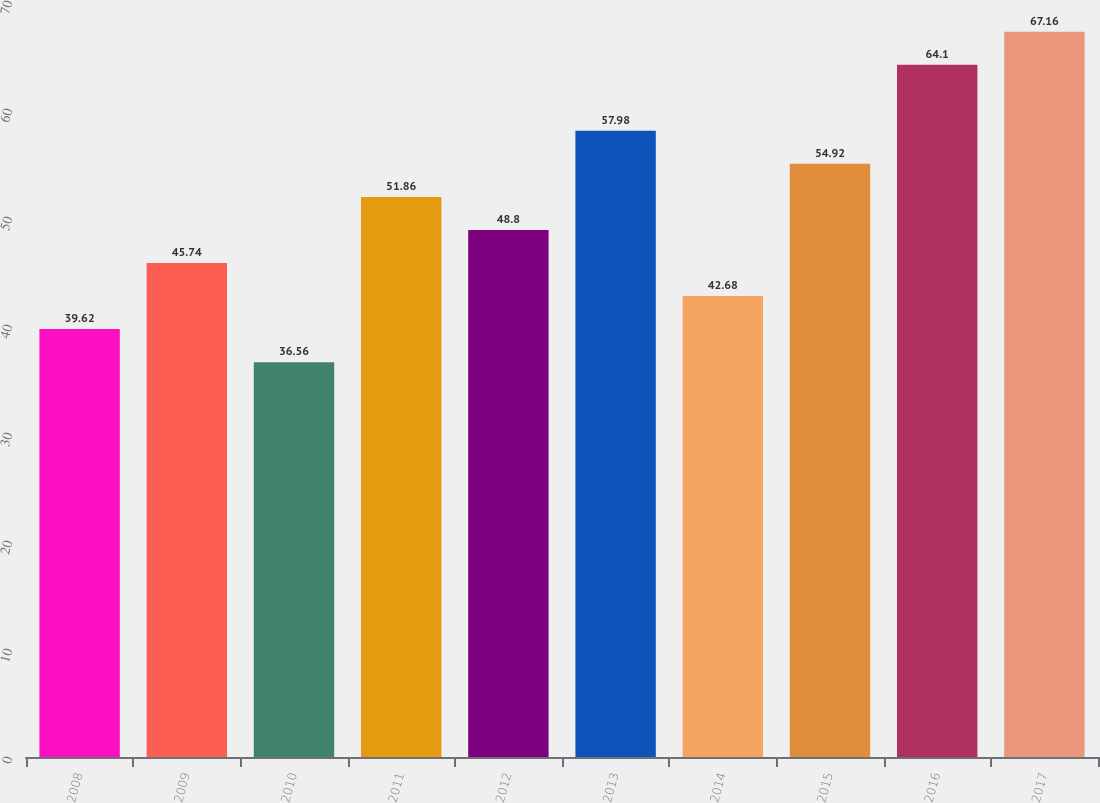Convert chart to OTSL. <chart><loc_0><loc_0><loc_500><loc_500><bar_chart><fcel>2008<fcel>2009<fcel>2010<fcel>2011<fcel>2012<fcel>2013<fcel>2014<fcel>2015<fcel>2016<fcel>2017<nl><fcel>39.62<fcel>45.74<fcel>36.56<fcel>51.86<fcel>48.8<fcel>57.98<fcel>42.68<fcel>54.92<fcel>64.1<fcel>67.16<nl></chart> 